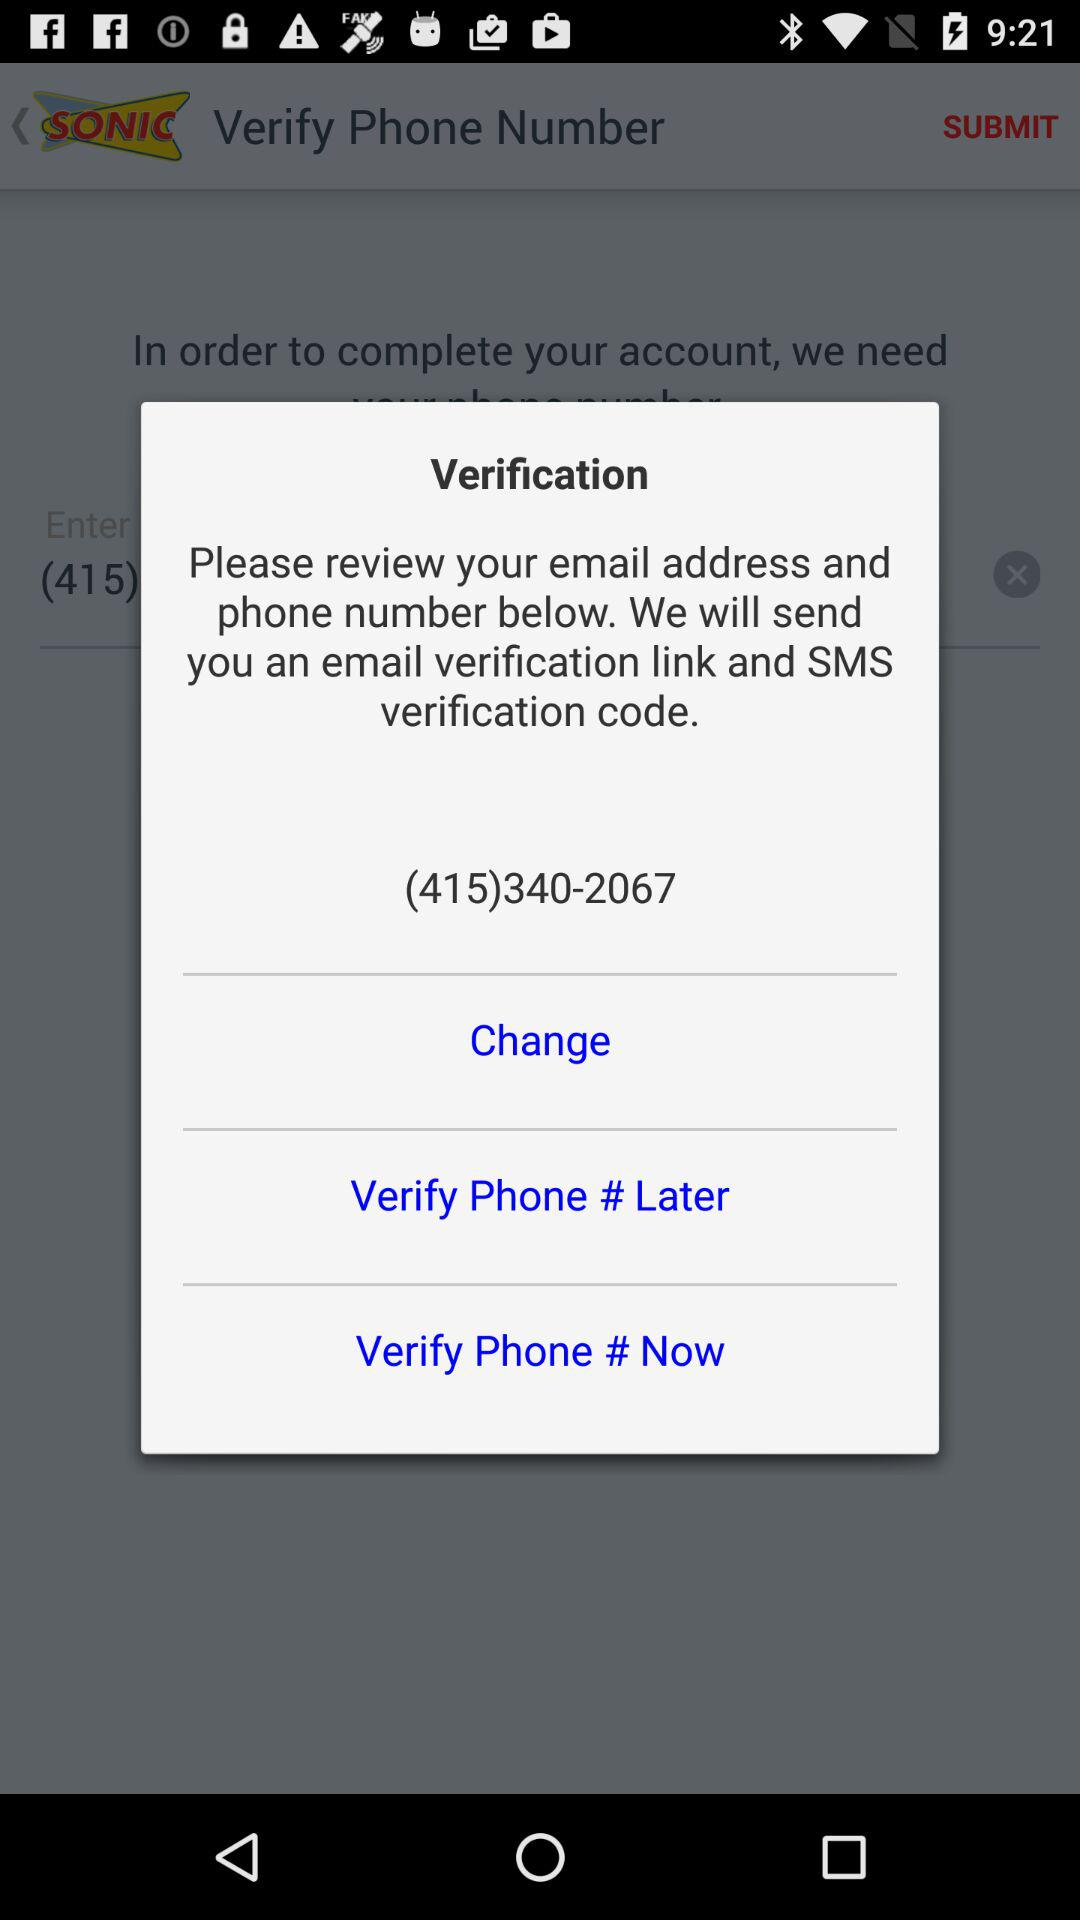What is the phone number available on the screen? The phone number available on the screen is (415)340-2067. 